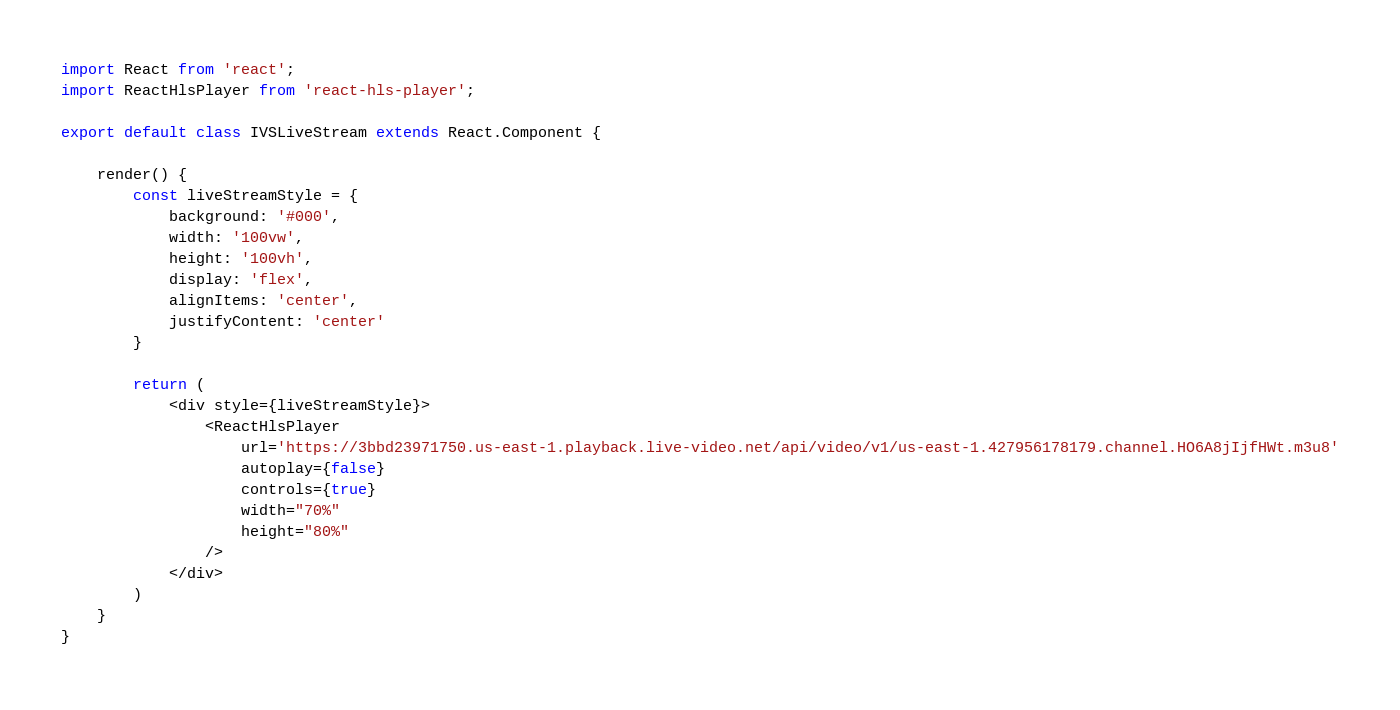<code> <loc_0><loc_0><loc_500><loc_500><_JavaScript_>import React from 'react';
import ReactHlsPlayer from 'react-hls-player';

export default class IVSLiveStream extends React.Component {

    render() {
        const liveStreamStyle = {
            background: '#000', 
            width: '100vw', 
            height: '100vh',
            display: 'flex',
            alignItems: 'center',
            justifyContent: 'center'
        }

        return (
            <div style={liveStreamStyle}>
                <ReactHlsPlayer
                    url='https://3bbd23971750.us-east-1.playback.live-video.net/api/video/v1/us-east-1.427956178179.channel.HO6A8jIjfHWt.m3u8'
                    autoplay={false}
                    controls={true}
                    width="70%"
                    height="80%"
                />
            </div>
        )
    }
}
</code> 